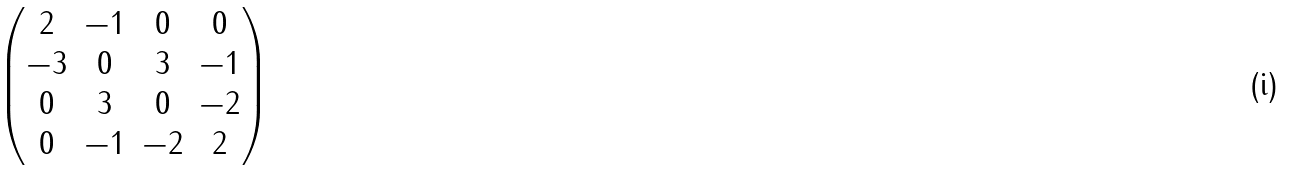Convert formula to latex. <formula><loc_0><loc_0><loc_500><loc_500>\begin{pmatrix} 2 & - 1 & 0 & 0 \\ - 3 & 0 & 3 & - 1 \\ 0 & 3 & 0 & - 2 \\ 0 & - 1 & - 2 & 2 \end{pmatrix}</formula> 